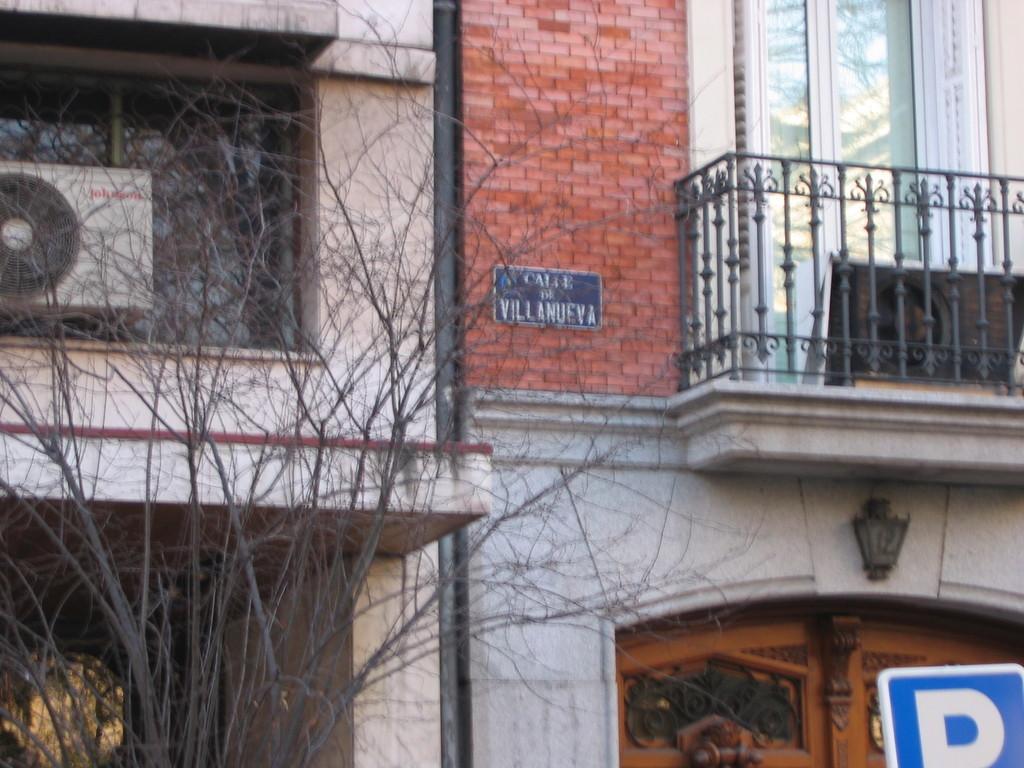Describe this image in one or two sentences. In this image, in the middle there are building, tree, railing, window, curtains, compressor, board, text. At the bottom there is a door, sign board. 